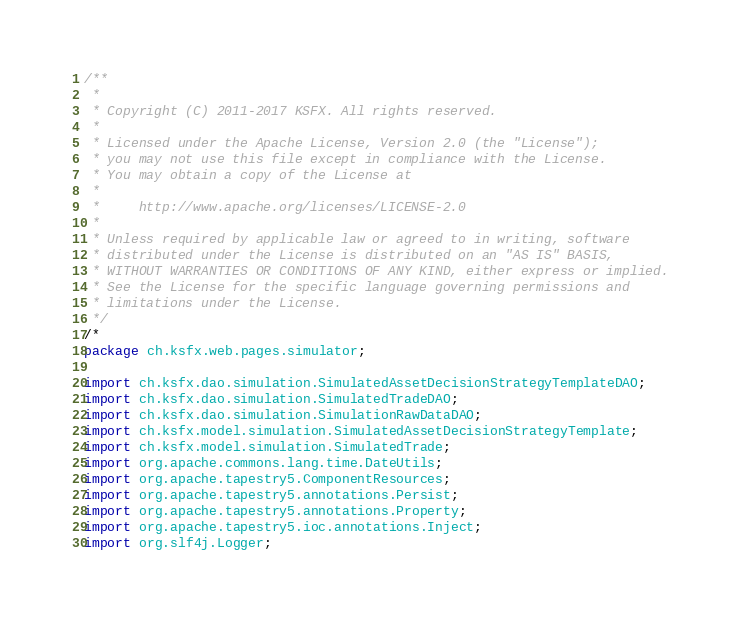<code> <loc_0><loc_0><loc_500><loc_500><_Java_>/**
 *
 * Copyright (C) 2011-2017 KSFX. All rights reserved.
 *
 * Licensed under the Apache License, Version 2.0 (the "License");
 * you may not use this file except in compliance with the License.
 * You may obtain a copy of the License at
 *
 *     http://www.apache.org/licenses/LICENSE-2.0
 *
 * Unless required by applicable law or agreed to in writing, software
 * distributed under the License is distributed on an "AS IS" BASIS,
 * WITHOUT WARRANTIES OR CONDITIONS OF ANY KIND, either express or implied.
 * See the License for the specific language governing permissions and
 * limitations under the License.
 */
/*
package ch.ksfx.web.pages.simulator;

import ch.ksfx.dao.simulation.SimulatedAssetDecisionStrategyTemplateDAO;
import ch.ksfx.dao.simulation.SimulatedTradeDAO;
import ch.ksfx.dao.simulation.SimulationRawDataDAO;
import ch.ksfx.model.simulation.SimulatedAssetDecisionStrategyTemplate;
import ch.ksfx.model.simulation.SimulatedTrade;
import org.apache.commons.lang.time.DateUtils;
import org.apache.tapestry5.ComponentResources;
import org.apache.tapestry5.annotations.Persist;
import org.apache.tapestry5.annotations.Property;
import org.apache.tapestry5.ioc.annotations.Inject;
import org.slf4j.Logger;</code> 